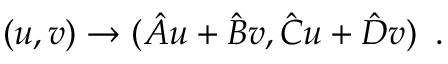Convert formula to latex. <formula><loc_0><loc_0><loc_500><loc_500>( u , v ) \rightarrow ( { { \hat { A } u + \hat { B } v } , { \hat { C } u + \hat { D } v } } ) \, .</formula> 